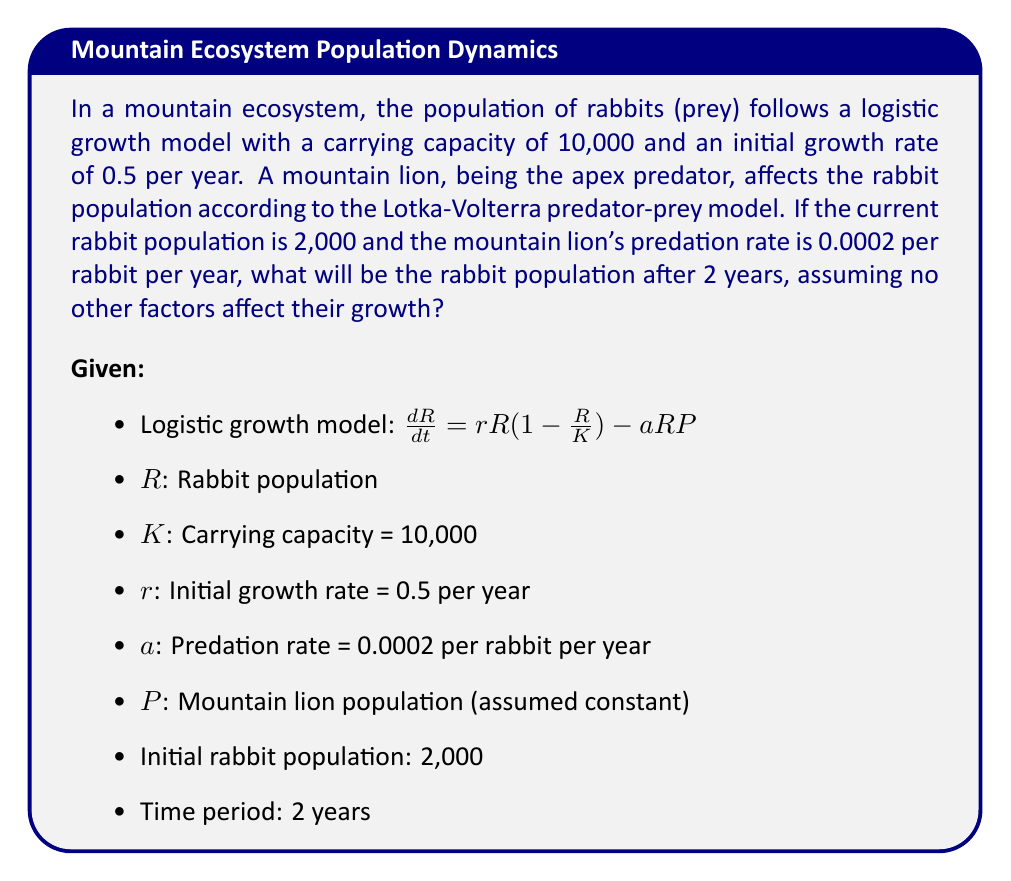Solve this math problem. To solve this problem, we need to use numerical methods, specifically the Runge-Kutta 4th order method (RK4), to approximate the solution of the differential equation.

Step 1: Set up the differential equation.
$$\frac{dR}{dt} = 0.5R(1-\frac{R}{10000}) - 0.0002RP$$

Step 2: Define the function for the rate of change.
$$f(R) = 0.5R(1-\frac{R}{10000}) - 0.0002RP$$

Step 3: Apply the RK4 method with a small time step, let's use $\Delta t = 0.1$ years.

For each step:
$$k_1 = f(R_n)$$
$$k_2 = f(R_n + \frac{\Delta t}{2}k_1)$$
$$k_3 = f(R_n + \frac{\Delta t}{2}k_2)$$
$$k_4 = f(R_n + \Delta t k_3)$$
$$R_{n+1} = R_n + \frac{\Delta t}{6}(k_1 + 2k_2 + 2k_3 + k_4)$$

Step 4: Implement the RK4 method for 20 steps (2 years / 0.1 years per step).

Initial values:
$R_0 = 2000$
$t_0 = 0$

After 20 iterations:
$R_{20} \approx 3105$ rabbits

Step 5: Verify the result by checking if it's reasonable:
- The population has increased, which is expected given the growth rate and current population below carrying capacity.
- The increase is less than purely logistic growth would predict due to predation.
- The final population is still below the carrying capacity.
Answer: 3105 rabbits 